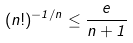Convert formula to latex. <formula><loc_0><loc_0><loc_500><loc_500>( n ! ) ^ { - 1 / n } \leq \frac { e } { n + 1 }</formula> 